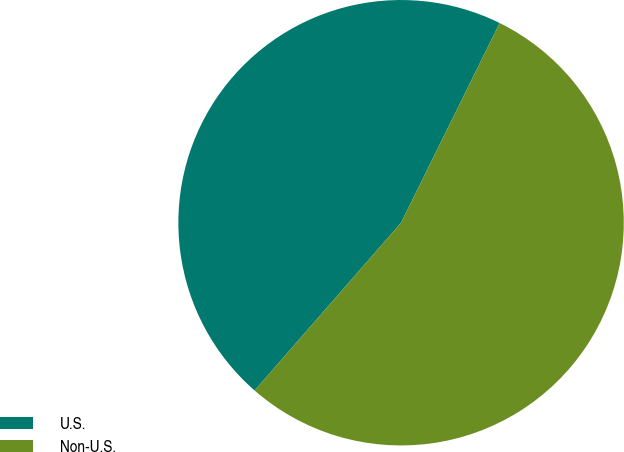Convert chart. <chart><loc_0><loc_0><loc_500><loc_500><pie_chart><fcel>U.S.<fcel>Non-U.S.<nl><fcel>45.88%<fcel>54.12%<nl></chart> 